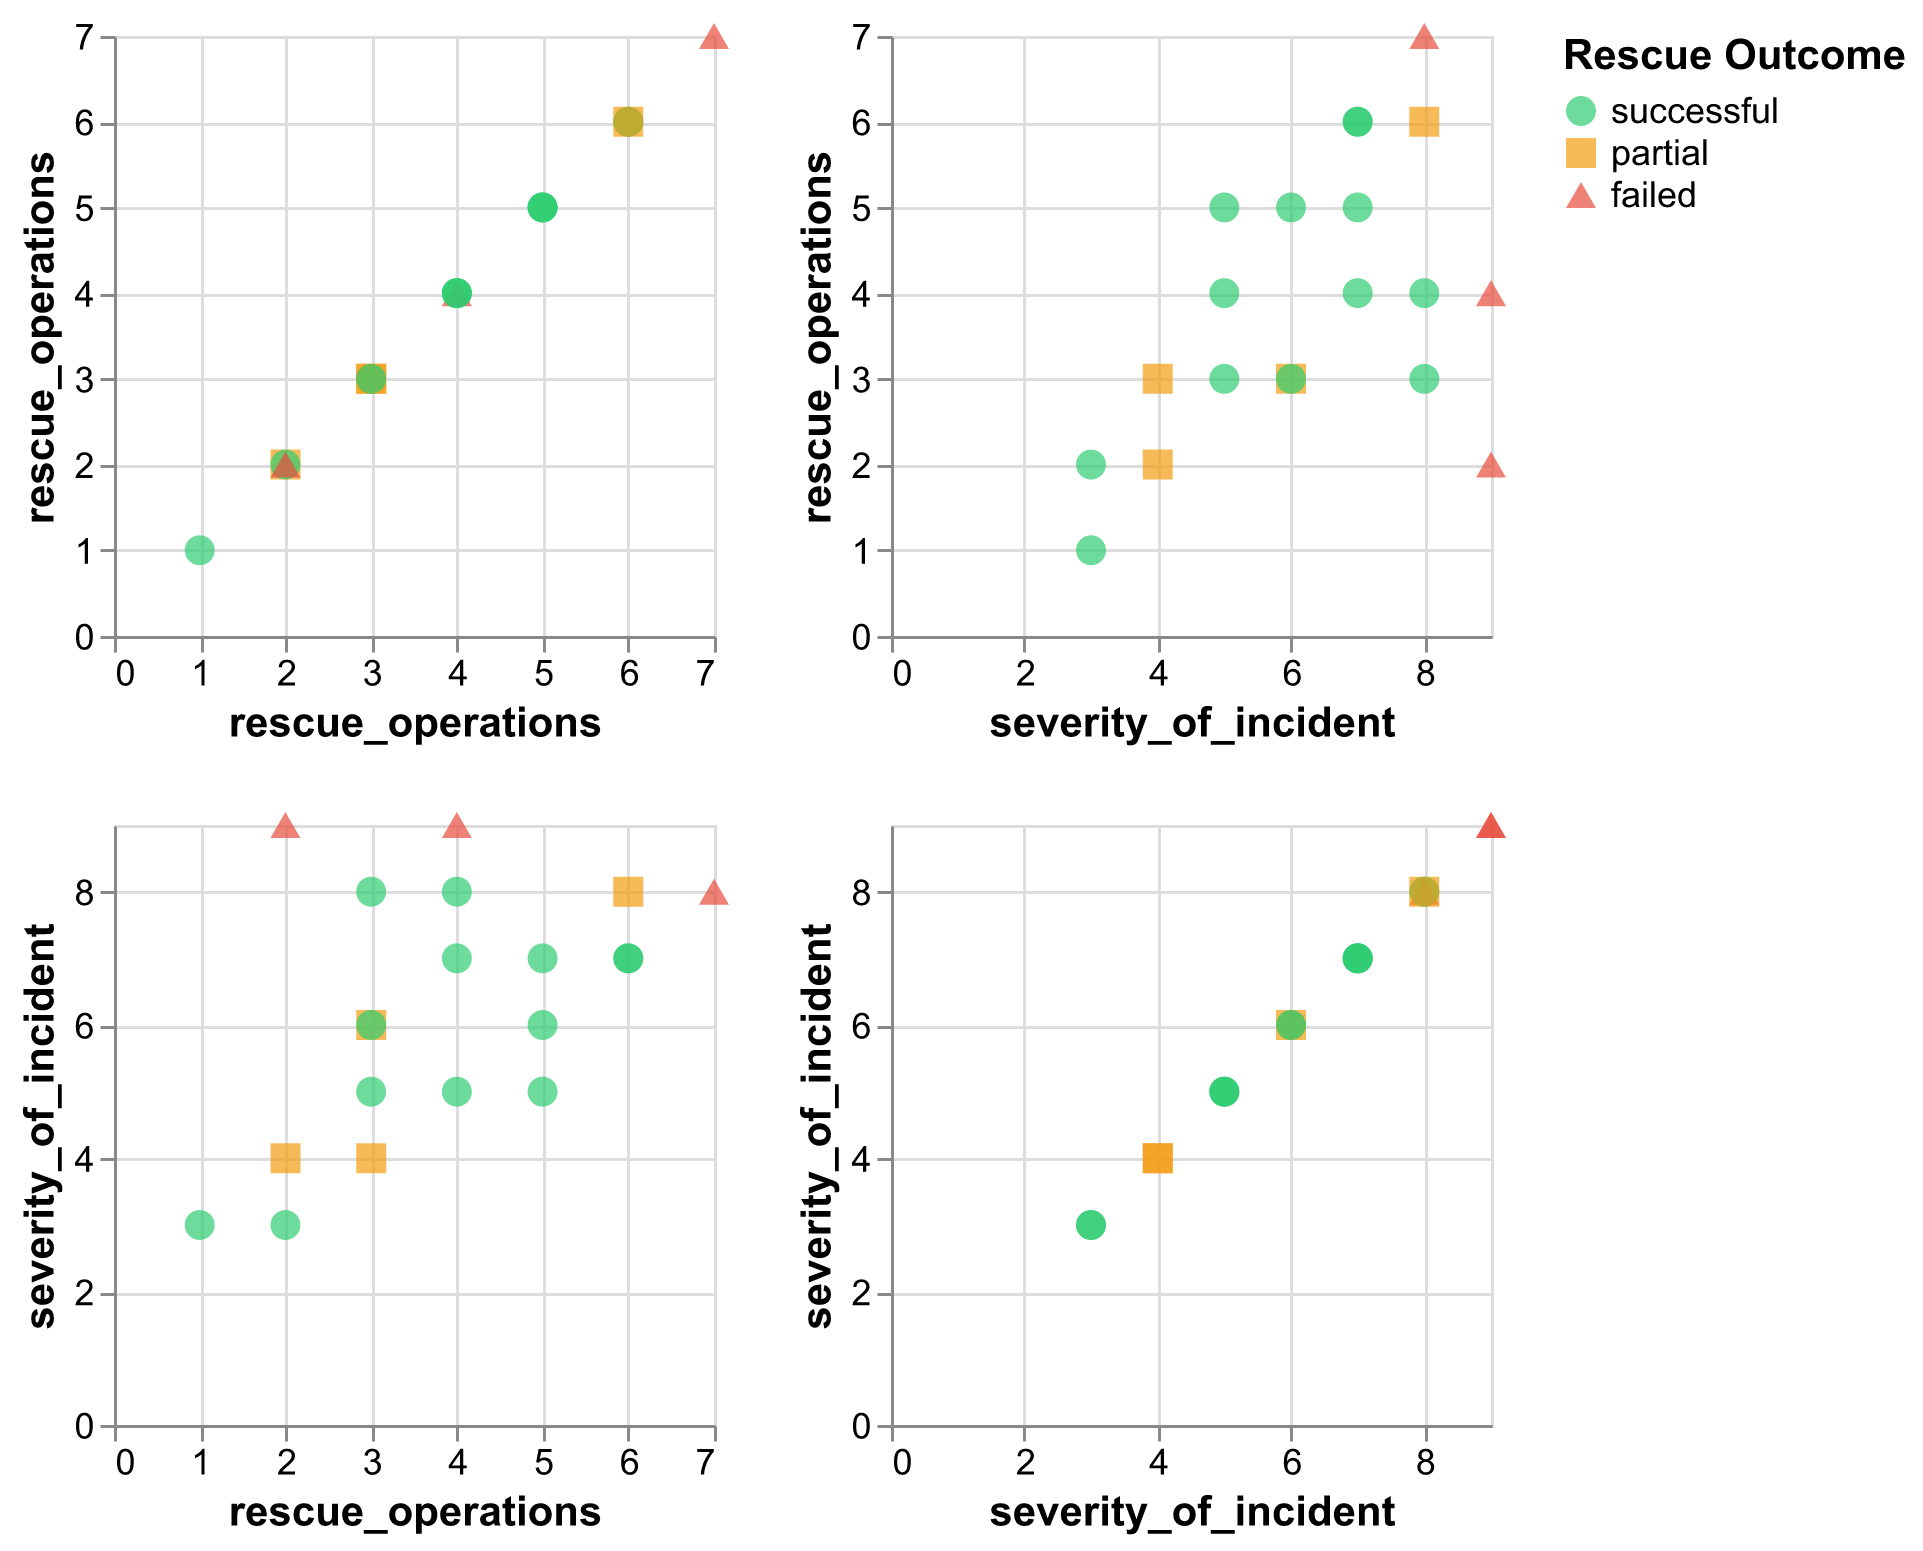How many data points in the matrix are associated with a "failed" outcome? Count the points marked with the "triangle-up" shape or colored in red, representing "failed" outcomes. There are three such points.
Answer: 3 Which outcome has the most data points: successful, partial, or failed? Tally the points associated with each outcome. "Successful" points (green circles) are most frequent, with multiple instances in each subplot.
Answer: Successful Are there more "successful" outcomes with a low number of rescue operations (1-3) or high number of rescue operations (4-7)? Compare the scatter plots for "successful" outcomes in the rescue operations range of 1-3 and 4-7. There are more "successful" outcomes in the 4-7 range.
Answer: High number (4-7) What relationship, if any, can be observed between the severity of incidents and the number of rescue operations for the "partial" outcomes? Look for the points marked as "partial" (orange squares) in the matrix. Partial outcomes mostly occur with lower rescue operations (around 2-4) and varying severities.
Answer: Lower rescue operations In the plots of "rescue operations" vs. "severity of incident," are there any clusters of "failed" outcomes? Observe the scatter plot with "rescue operations" on one axis and "severity of incident" on the other, focusing on the red triangles. "Failed" outcomes cluster around higher severities (7-9).
Answer: High severities (7-9) How many incidents with a severity of 7 resulted in a "successful" outcome? Find the scatter points where severity is 7 and check for green circles ("successful"). There are three such incidents.
Answer: 3 Does increasing the number of rescue operations generally correlate with the type of outcome? Analyze the scatter plots to see how the number of operations affects outcomes. Higher rescue operations (4-7) are often associated with successful outcomes, while lower operations vary more.
Answer: High operations often successful Which outcome sees the widest range of severity levels across the incidents? Compare the range of severity levels among points for each outcome type. Successful outcomes (green circles) appear over a wide range from 3 to 8.
Answer: Successful 